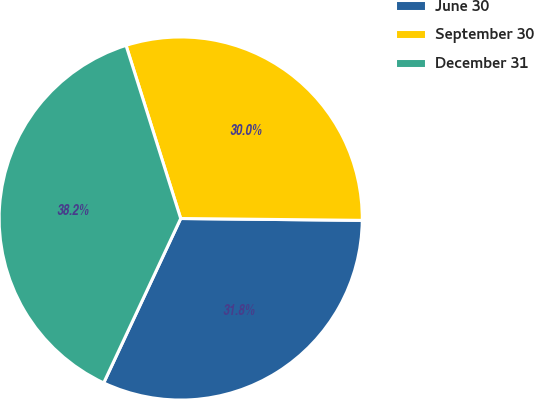<chart> <loc_0><loc_0><loc_500><loc_500><pie_chart><fcel>June 30<fcel>September 30<fcel>December 31<nl><fcel>31.81%<fcel>30.03%<fcel>38.16%<nl></chart> 